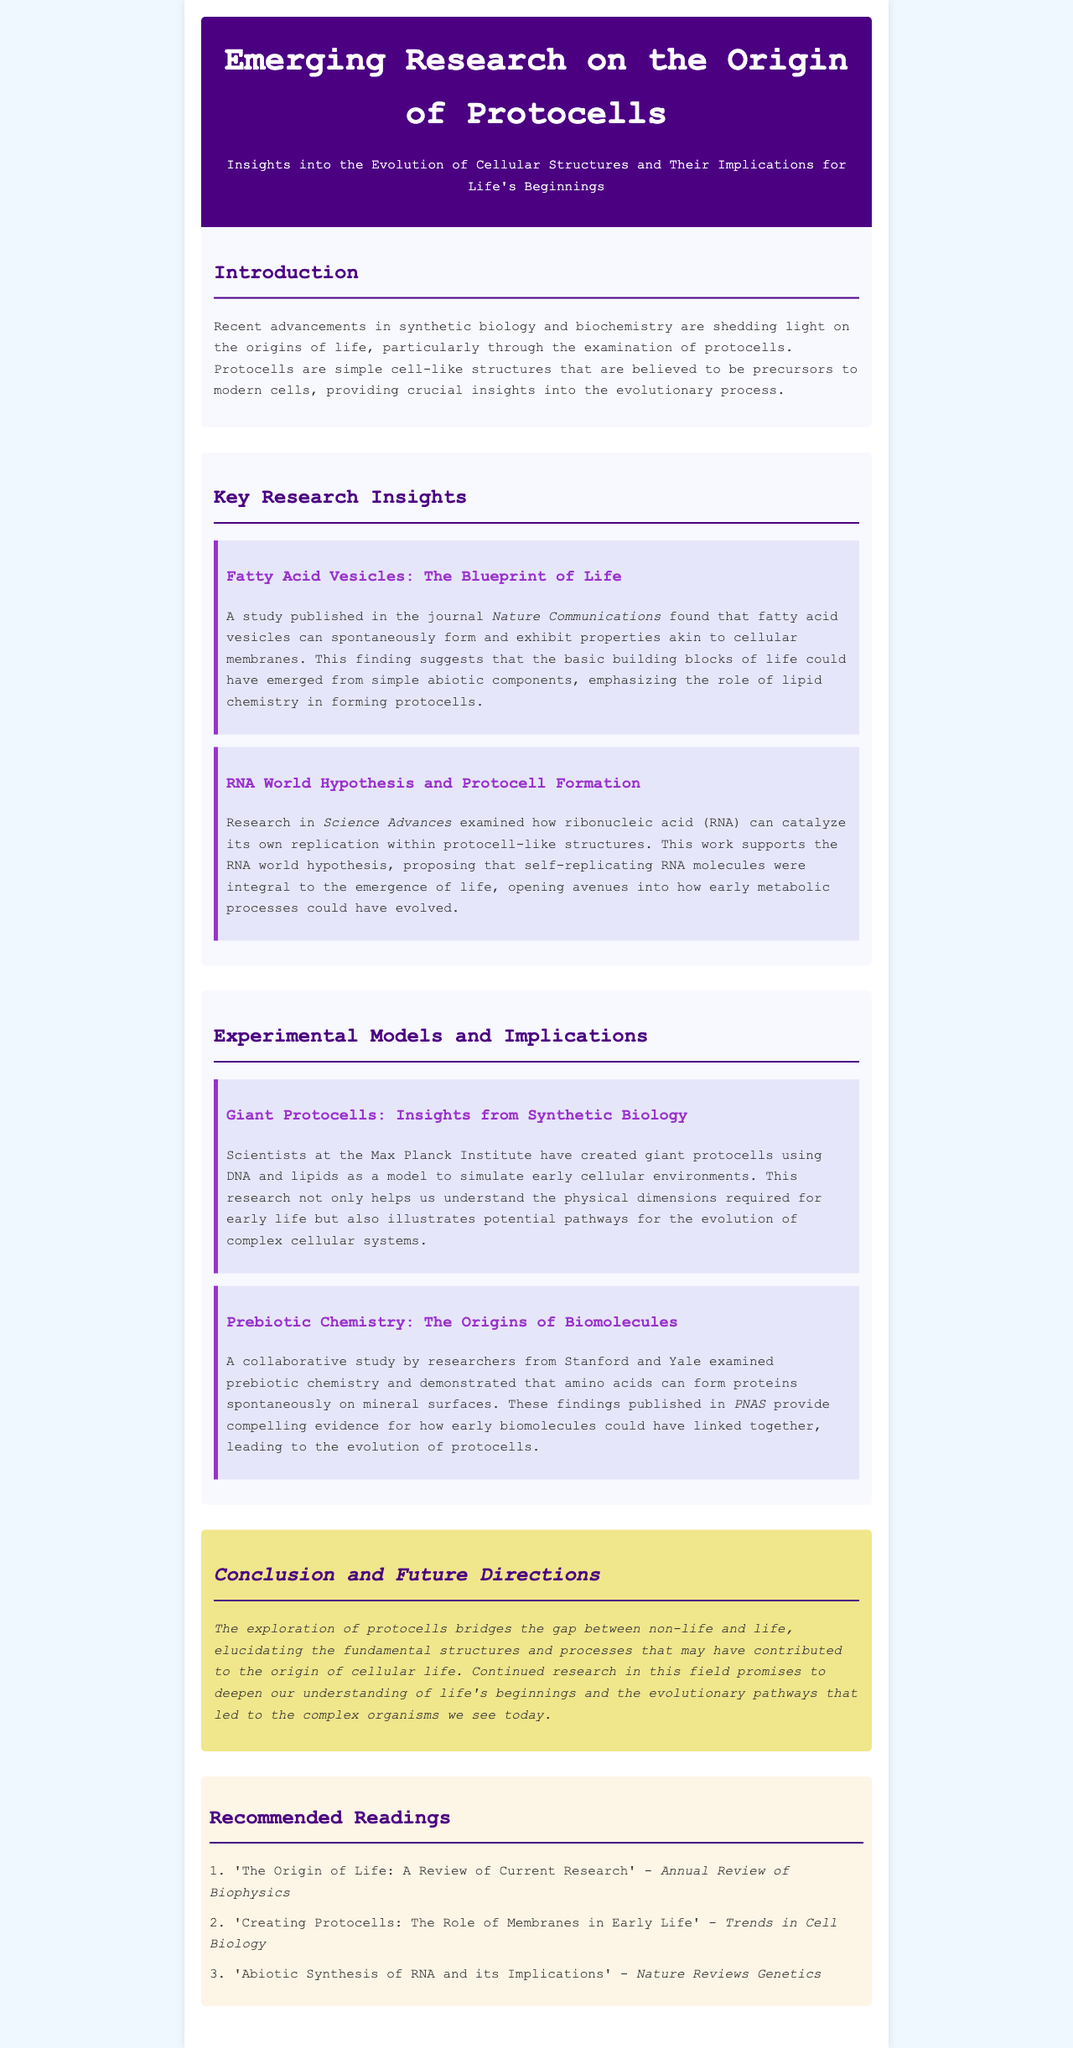What are protocells? Protocells are simple cell-like structures that are believed to be precursors to modern cells, providing crucial insights into the evolutionary process.
Answer: Simple cell-like structures Which journal published research on fatty acid vesicles? The document mentions that a study on fatty acid vesicles was published in the journal Nature Communications.
Answer: Nature Communications What hypothesis does the study on RNA support? The research discussed in the document supports the RNA world hypothesis, which proposes that self-replicating RNA molecules were integral to the emergence of life.
Answer: RNA world hypothesis Who conducted research on giant protocells? The research on giant protocells was conducted by scientists at the Max Planck Institute.
Answer: Max Planck Institute What was demonstrated by the collaborative study from Stanford and Yale? The collaborative study examined prebiotic chemistry and demonstrated that amino acids can form proteins spontaneously on mineral surfaces.
Answer: Amino acids can form proteins spontaneously What does the conclusion highlight about protocells? The conclusion highlights that the exploration of protocells bridges the gap between non-life and life, elucidating fundamental structures and processes that may have contributed to the origin of cellular life.
Answer: Bridges the gap between non-life and life Name a recommended reading from the newsletter. The document lists 'The Origin of Life: A Review of Current Research' as a recommended reading.
Answer: The Origin of Life: A Review of Current Research In which journal was the study about prebiotic chemistry published? The findings regarding prebiotic chemistry were published in PNAS.
Answer: PNAS 